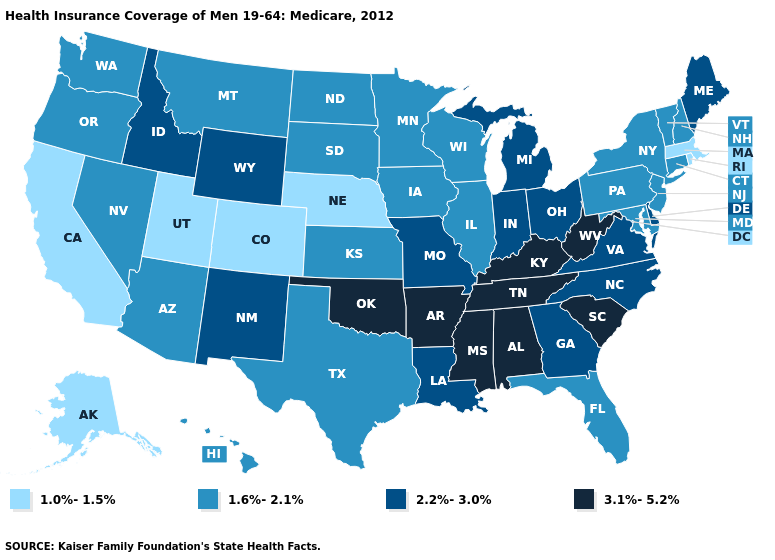Name the states that have a value in the range 1.0%-1.5%?
Concise answer only. Alaska, California, Colorado, Massachusetts, Nebraska, Rhode Island, Utah. Name the states that have a value in the range 1.6%-2.1%?
Short answer required. Arizona, Connecticut, Florida, Hawaii, Illinois, Iowa, Kansas, Maryland, Minnesota, Montana, Nevada, New Hampshire, New Jersey, New York, North Dakota, Oregon, Pennsylvania, South Dakota, Texas, Vermont, Washington, Wisconsin. Which states have the lowest value in the USA?
Answer briefly. Alaska, California, Colorado, Massachusetts, Nebraska, Rhode Island, Utah. Does the map have missing data?
Answer briefly. No. What is the highest value in the Northeast ?
Quick response, please. 2.2%-3.0%. Does Alaska have the lowest value in the West?
Write a very short answer. Yes. What is the highest value in the Northeast ?
Answer briefly. 2.2%-3.0%. Name the states that have a value in the range 1.0%-1.5%?
Write a very short answer. Alaska, California, Colorado, Massachusetts, Nebraska, Rhode Island, Utah. What is the value of Iowa?
Keep it brief. 1.6%-2.1%. Does the first symbol in the legend represent the smallest category?
Keep it brief. Yes. Which states hav the highest value in the West?
Quick response, please. Idaho, New Mexico, Wyoming. Does Idaho have the highest value in the West?
Answer briefly. Yes. Which states have the highest value in the USA?
Write a very short answer. Alabama, Arkansas, Kentucky, Mississippi, Oklahoma, South Carolina, Tennessee, West Virginia. 